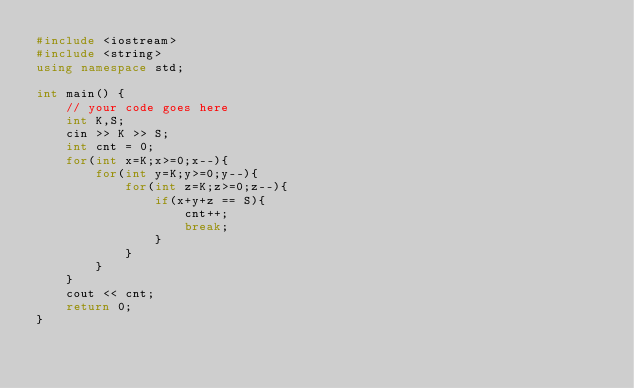Convert code to text. <code><loc_0><loc_0><loc_500><loc_500><_C++_>#include <iostream>
#include <string>
using namespace std;

int main() {
	// your code goes here
	int K,S;
	cin >> K >> S;
	int cnt = 0;
	for(int x=K;x>=0;x--){
		for(int y=K;y>=0;y--){
			for(int z=K;z>=0;z--){
				if(x+y+z == S){
					cnt++;
					break;
				}
			}
		}
	}
	cout << cnt;
	return 0;
}</code> 